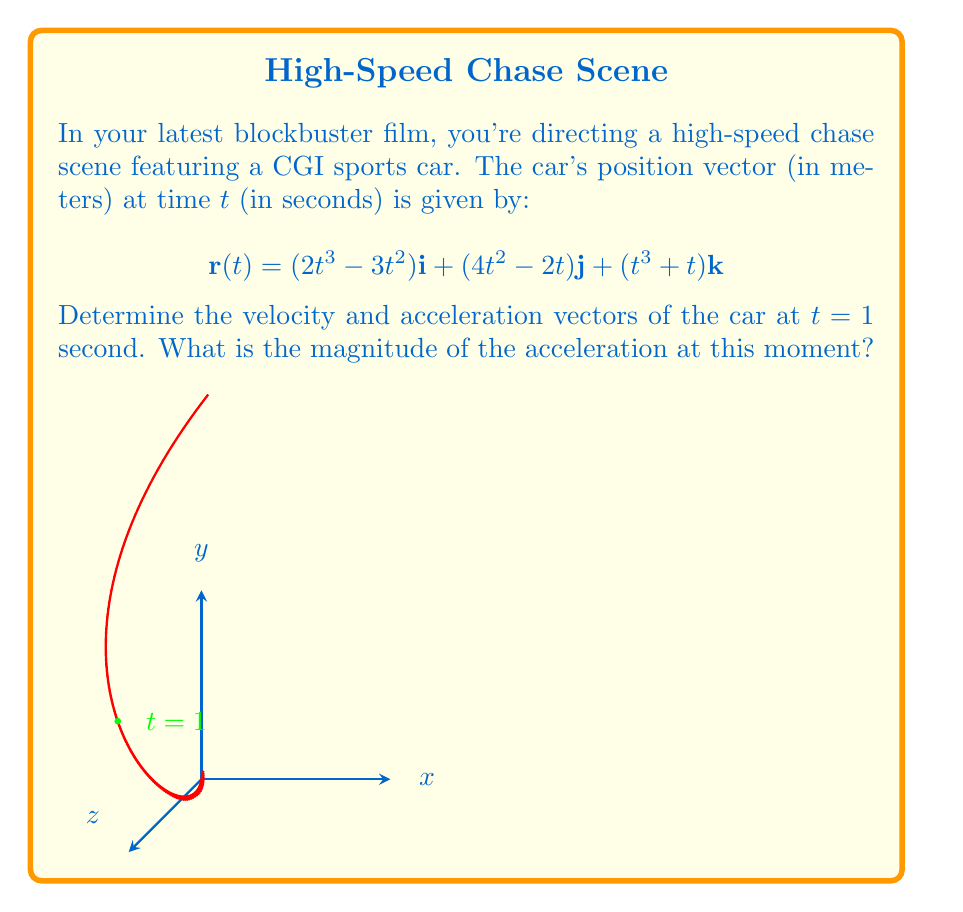Help me with this question. Let's approach this step-by-step:

1) First, we need to find the velocity vector $\mathbf{v}(t)$. This is the first derivative of the position vector:

   $$\mathbf{v}(t) = \frac{d\mathbf{r}}{dt} = (6t^2 - 6t)\mathbf{i} + (8t - 2)\mathbf{j} + (3t^2 + 1)\mathbf{k}$$

2) Next, we find the acceleration vector $\mathbf{a}(t)$, which is the second derivative of the position vector or the first derivative of the velocity vector:

   $$\mathbf{a}(t) = \frac{d\mathbf{v}}{dt} = (12t - 6)\mathbf{i} + 8\mathbf{j} + 6t\mathbf{k}$$

3) Now, we evaluate the velocity vector at $t = 1$:

   $$\mathbf{v}(1) = (6 - 6)\mathbf{i} + (8 - 2)\mathbf{j} + (3 + 1)\mathbf{k} = 6\mathbf{j} + 4\mathbf{k}$$

4) We also evaluate the acceleration vector at $t = 1$:

   $$\mathbf{a}(1) = (12 - 6)\mathbf{i} + 8\mathbf{j} + 6\mathbf{k} = 6\mathbf{i} + 8\mathbf{j} + 6\mathbf{k}$$

5) To find the magnitude of the acceleration at $t = 1$, we use the formula:

   $$|\mathbf{a}(1)| = \sqrt{6^2 + 8^2 + 6^2} = \sqrt{36 + 64 + 36} = \sqrt{136} = 2\sqrt{34}$$
Answer: $\mathbf{v}(1) = 6\mathbf{j} + 4\mathbf{k}$, $\mathbf{a}(1) = 6\mathbf{i} + 8\mathbf{j} + 6\mathbf{k}$, $|\mathbf{a}(1)| = 2\sqrt{34}$ m/s² 